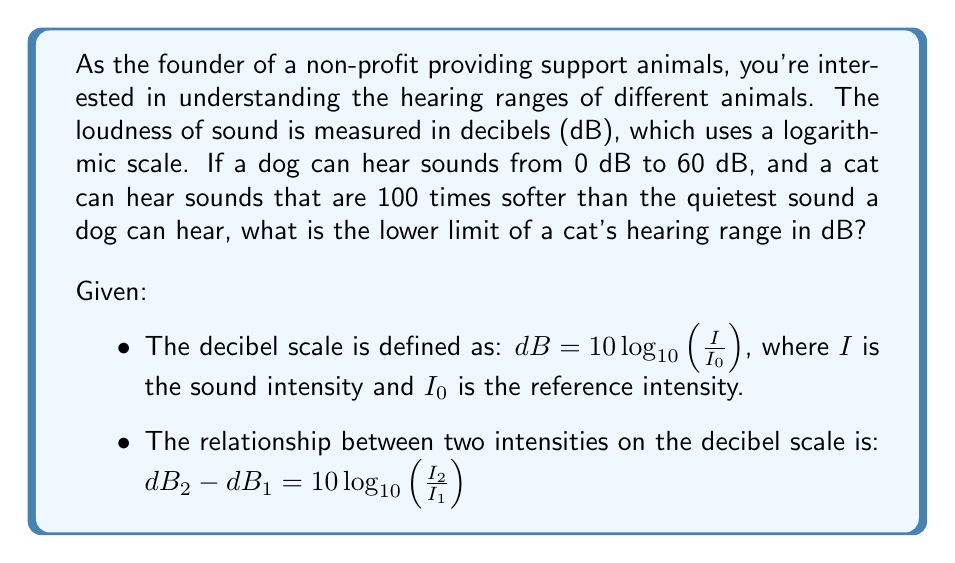Can you answer this question? Let's approach this step-by-step:

1) The lower limit of a dog's hearing range is 0 dB.

2) We're told that a cat can hear sounds 100 times softer than this. This means the intensity of the softest sound a cat can hear ($I_{cat}$) is related to the intensity of the softest sound a dog can hear ($I_{dog}$) by:

   $I_{cat} = \frac{I_{dog}}{100}$

3) We can use the relationship between two intensities on the decibel scale:

   $dB_{cat} - dB_{dog} = 10 \log_{10}(\frac{I_{cat}}{I_{dog}})$

4) Substituting what we know:

   $dB_{cat} - 0 = 10 \log_{10}(\frac{I_{dog}/100}{I_{dog}})$

5) Simplify:

   $dB_{cat} = 10 \log_{10}(\frac{1}{100}) = 10 \log_{10}(0.01)$

6) Using the logarithm property $\log_a(x) = -\log_a(\frac{1}{x})$:

   $dB_{cat} = -10 \log_{10}(100)$

7) $\log_{10}(100) = 2$, so:

   $dB_{cat} = -10 * 2 = -20$

Therefore, the lower limit of a cat's hearing range is -20 dB.
Answer: The lower limit of a cat's hearing range is -20 dB. 